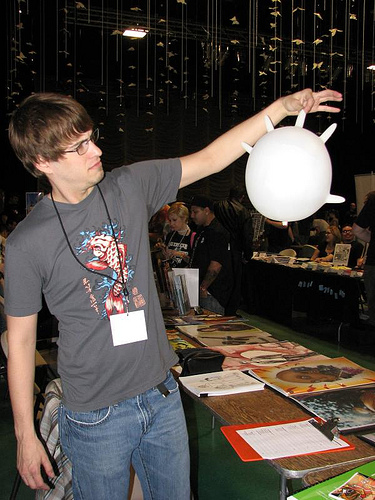<image>
Can you confirm if the name tag is under the shirt? No. The name tag is not positioned under the shirt. The vertical relationship between these objects is different. 